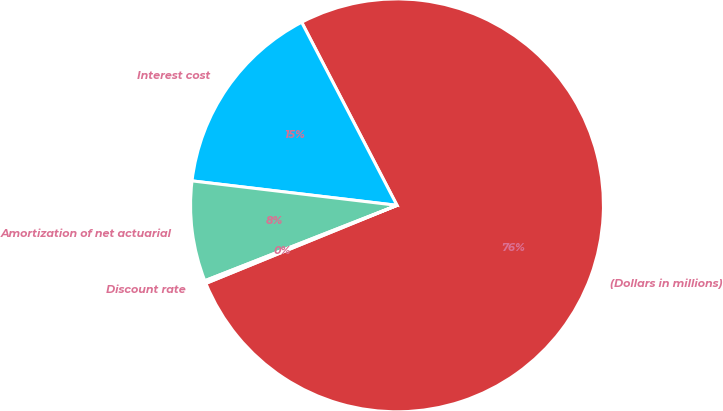Convert chart. <chart><loc_0><loc_0><loc_500><loc_500><pie_chart><fcel>(Dollars in millions)<fcel>Interest cost<fcel>Amortization of net actuarial<fcel>Discount rate<nl><fcel>76.47%<fcel>15.47%<fcel>7.84%<fcel>0.22%<nl></chart> 